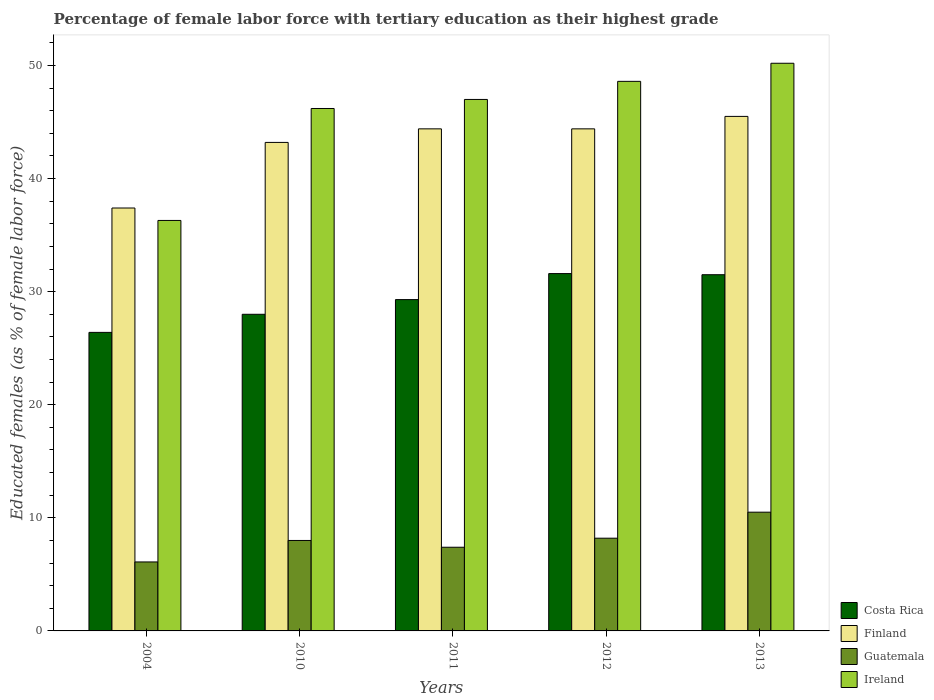How many different coloured bars are there?
Your answer should be compact. 4. How many groups of bars are there?
Give a very brief answer. 5. What is the label of the 5th group of bars from the left?
Your answer should be very brief. 2013. In how many cases, is the number of bars for a given year not equal to the number of legend labels?
Ensure brevity in your answer.  0. What is the percentage of female labor force with tertiary education in Costa Rica in 2012?
Ensure brevity in your answer.  31.6. Across all years, what is the maximum percentage of female labor force with tertiary education in Costa Rica?
Give a very brief answer. 31.6. Across all years, what is the minimum percentage of female labor force with tertiary education in Ireland?
Offer a very short reply. 36.3. In which year was the percentage of female labor force with tertiary education in Ireland minimum?
Ensure brevity in your answer.  2004. What is the total percentage of female labor force with tertiary education in Ireland in the graph?
Give a very brief answer. 228.3. What is the difference between the percentage of female labor force with tertiary education in Costa Rica in 2004 and that in 2010?
Your response must be concise. -1.6. What is the difference between the percentage of female labor force with tertiary education in Finland in 2012 and the percentage of female labor force with tertiary education in Guatemala in 2004?
Offer a terse response. 38.3. What is the average percentage of female labor force with tertiary education in Guatemala per year?
Your answer should be compact. 8.04. In the year 2010, what is the difference between the percentage of female labor force with tertiary education in Ireland and percentage of female labor force with tertiary education in Costa Rica?
Your response must be concise. 18.2. What is the ratio of the percentage of female labor force with tertiary education in Guatemala in 2011 to that in 2013?
Give a very brief answer. 0.7. What is the difference between the highest and the second highest percentage of female labor force with tertiary education in Ireland?
Provide a short and direct response. 1.6. What is the difference between the highest and the lowest percentage of female labor force with tertiary education in Ireland?
Give a very brief answer. 13.9. In how many years, is the percentage of female labor force with tertiary education in Costa Rica greater than the average percentage of female labor force with tertiary education in Costa Rica taken over all years?
Provide a succinct answer. 2. Is the sum of the percentage of female labor force with tertiary education in Ireland in 2004 and 2012 greater than the maximum percentage of female labor force with tertiary education in Guatemala across all years?
Provide a succinct answer. Yes. Is it the case that in every year, the sum of the percentage of female labor force with tertiary education in Finland and percentage of female labor force with tertiary education in Costa Rica is greater than the sum of percentage of female labor force with tertiary education in Ireland and percentage of female labor force with tertiary education in Guatemala?
Your answer should be very brief. Yes. What does the 1st bar from the left in 2004 represents?
Keep it short and to the point. Costa Rica. What does the 2nd bar from the right in 2004 represents?
Keep it short and to the point. Guatemala. How many bars are there?
Give a very brief answer. 20. What is the difference between two consecutive major ticks on the Y-axis?
Provide a short and direct response. 10. Are the values on the major ticks of Y-axis written in scientific E-notation?
Your response must be concise. No. Where does the legend appear in the graph?
Keep it short and to the point. Bottom right. What is the title of the graph?
Offer a terse response. Percentage of female labor force with tertiary education as their highest grade. Does "Nicaragua" appear as one of the legend labels in the graph?
Offer a terse response. No. What is the label or title of the X-axis?
Make the answer very short. Years. What is the label or title of the Y-axis?
Offer a terse response. Educated females (as % of female labor force). What is the Educated females (as % of female labor force) in Costa Rica in 2004?
Offer a terse response. 26.4. What is the Educated females (as % of female labor force) in Finland in 2004?
Offer a very short reply. 37.4. What is the Educated females (as % of female labor force) in Guatemala in 2004?
Keep it short and to the point. 6.1. What is the Educated females (as % of female labor force) of Ireland in 2004?
Offer a very short reply. 36.3. What is the Educated females (as % of female labor force) in Finland in 2010?
Ensure brevity in your answer.  43.2. What is the Educated females (as % of female labor force) of Ireland in 2010?
Provide a succinct answer. 46.2. What is the Educated females (as % of female labor force) of Costa Rica in 2011?
Offer a terse response. 29.3. What is the Educated females (as % of female labor force) of Finland in 2011?
Give a very brief answer. 44.4. What is the Educated females (as % of female labor force) in Guatemala in 2011?
Your answer should be very brief. 7.4. What is the Educated females (as % of female labor force) in Costa Rica in 2012?
Keep it short and to the point. 31.6. What is the Educated females (as % of female labor force) of Finland in 2012?
Give a very brief answer. 44.4. What is the Educated females (as % of female labor force) in Guatemala in 2012?
Offer a very short reply. 8.2. What is the Educated females (as % of female labor force) in Ireland in 2012?
Make the answer very short. 48.6. What is the Educated females (as % of female labor force) in Costa Rica in 2013?
Your response must be concise. 31.5. What is the Educated females (as % of female labor force) in Finland in 2013?
Make the answer very short. 45.5. What is the Educated females (as % of female labor force) of Ireland in 2013?
Offer a terse response. 50.2. Across all years, what is the maximum Educated females (as % of female labor force) of Costa Rica?
Your response must be concise. 31.6. Across all years, what is the maximum Educated females (as % of female labor force) in Finland?
Keep it short and to the point. 45.5. Across all years, what is the maximum Educated females (as % of female labor force) in Ireland?
Provide a succinct answer. 50.2. Across all years, what is the minimum Educated females (as % of female labor force) in Costa Rica?
Offer a very short reply. 26.4. Across all years, what is the minimum Educated females (as % of female labor force) in Finland?
Ensure brevity in your answer.  37.4. Across all years, what is the minimum Educated females (as % of female labor force) in Guatemala?
Your answer should be compact. 6.1. Across all years, what is the minimum Educated females (as % of female labor force) of Ireland?
Provide a succinct answer. 36.3. What is the total Educated females (as % of female labor force) of Costa Rica in the graph?
Ensure brevity in your answer.  146.8. What is the total Educated females (as % of female labor force) in Finland in the graph?
Give a very brief answer. 214.9. What is the total Educated females (as % of female labor force) of Guatemala in the graph?
Make the answer very short. 40.2. What is the total Educated females (as % of female labor force) of Ireland in the graph?
Offer a terse response. 228.3. What is the difference between the Educated females (as % of female labor force) in Finland in 2004 and that in 2010?
Your answer should be very brief. -5.8. What is the difference between the Educated females (as % of female labor force) of Guatemala in 2004 and that in 2010?
Make the answer very short. -1.9. What is the difference between the Educated females (as % of female labor force) in Ireland in 2004 and that in 2010?
Your answer should be very brief. -9.9. What is the difference between the Educated females (as % of female labor force) of Costa Rica in 2004 and that in 2012?
Your answer should be compact. -5.2. What is the difference between the Educated females (as % of female labor force) of Finland in 2004 and that in 2012?
Your answer should be compact. -7. What is the difference between the Educated females (as % of female labor force) of Guatemala in 2004 and that in 2012?
Your response must be concise. -2.1. What is the difference between the Educated females (as % of female labor force) in Costa Rica in 2004 and that in 2013?
Provide a short and direct response. -5.1. What is the difference between the Educated females (as % of female labor force) of Guatemala in 2004 and that in 2013?
Provide a short and direct response. -4.4. What is the difference between the Educated females (as % of female labor force) in Costa Rica in 2010 and that in 2011?
Your response must be concise. -1.3. What is the difference between the Educated females (as % of female labor force) of Finland in 2010 and that in 2011?
Make the answer very short. -1.2. What is the difference between the Educated females (as % of female labor force) in Guatemala in 2010 and that in 2011?
Make the answer very short. 0.6. What is the difference between the Educated females (as % of female labor force) in Ireland in 2010 and that in 2011?
Make the answer very short. -0.8. What is the difference between the Educated females (as % of female labor force) of Guatemala in 2010 and that in 2013?
Your answer should be compact. -2.5. What is the difference between the Educated females (as % of female labor force) in Finland in 2011 and that in 2012?
Keep it short and to the point. 0. What is the difference between the Educated females (as % of female labor force) in Guatemala in 2011 and that in 2012?
Provide a short and direct response. -0.8. What is the difference between the Educated females (as % of female labor force) of Ireland in 2011 and that in 2012?
Make the answer very short. -1.6. What is the difference between the Educated females (as % of female labor force) in Finland in 2011 and that in 2013?
Offer a very short reply. -1.1. What is the difference between the Educated females (as % of female labor force) in Guatemala in 2011 and that in 2013?
Give a very brief answer. -3.1. What is the difference between the Educated females (as % of female labor force) of Ireland in 2011 and that in 2013?
Your answer should be compact. -3.2. What is the difference between the Educated females (as % of female labor force) in Finland in 2012 and that in 2013?
Offer a terse response. -1.1. What is the difference between the Educated females (as % of female labor force) in Costa Rica in 2004 and the Educated females (as % of female labor force) in Finland in 2010?
Your answer should be compact. -16.8. What is the difference between the Educated females (as % of female labor force) in Costa Rica in 2004 and the Educated females (as % of female labor force) in Ireland in 2010?
Ensure brevity in your answer.  -19.8. What is the difference between the Educated females (as % of female labor force) of Finland in 2004 and the Educated females (as % of female labor force) of Guatemala in 2010?
Your response must be concise. 29.4. What is the difference between the Educated females (as % of female labor force) in Finland in 2004 and the Educated females (as % of female labor force) in Ireland in 2010?
Offer a very short reply. -8.8. What is the difference between the Educated females (as % of female labor force) in Guatemala in 2004 and the Educated females (as % of female labor force) in Ireland in 2010?
Give a very brief answer. -40.1. What is the difference between the Educated females (as % of female labor force) of Costa Rica in 2004 and the Educated females (as % of female labor force) of Ireland in 2011?
Offer a terse response. -20.6. What is the difference between the Educated females (as % of female labor force) in Finland in 2004 and the Educated females (as % of female labor force) in Ireland in 2011?
Your answer should be compact. -9.6. What is the difference between the Educated females (as % of female labor force) in Guatemala in 2004 and the Educated females (as % of female labor force) in Ireland in 2011?
Your answer should be compact. -40.9. What is the difference between the Educated females (as % of female labor force) of Costa Rica in 2004 and the Educated females (as % of female labor force) of Finland in 2012?
Your response must be concise. -18. What is the difference between the Educated females (as % of female labor force) of Costa Rica in 2004 and the Educated females (as % of female labor force) of Guatemala in 2012?
Your answer should be very brief. 18.2. What is the difference between the Educated females (as % of female labor force) in Costa Rica in 2004 and the Educated females (as % of female labor force) in Ireland in 2012?
Provide a short and direct response. -22.2. What is the difference between the Educated females (as % of female labor force) of Finland in 2004 and the Educated females (as % of female labor force) of Guatemala in 2012?
Your response must be concise. 29.2. What is the difference between the Educated females (as % of female labor force) of Finland in 2004 and the Educated females (as % of female labor force) of Ireland in 2012?
Provide a short and direct response. -11.2. What is the difference between the Educated females (as % of female labor force) of Guatemala in 2004 and the Educated females (as % of female labor force) of Ireland in 2012?
Make the answer very short. -42.5. What is the difference between the Educated females (as % of female labor force) in Costa Rica in 2004 and the Educated females (as % of female labor force) in Finland in 2013?
Provide a succinct answer. -19.1. What is the difference between the Educated females (as % of female labor force) in Costa Rica in 2004 and the Educated females (as % of female labor force) in Ireland in 2013?
Offer a terse response. -23.8. What is the difference between the Educated females (as % of female labor force) in Finland in 2004 and the Educated females (as % of female labor force) in Guatemala in 2013?
Provide a short and direct response. 26.9. What is the difference between the Educated females (as % of female labor force) of Guatemala in 2004 and the Educated females (as % of female labor force) of Ireland in 2013?
Keep it short and to the point. -44.1. What is the difference between the Educated females (as % of female labor force) in Costa Rica in 2010 and the Educated females (as % of female labor force) in Finland in 2011?
Keep it short and to the point. -16.4. What is the difference between the Educated females (as % of female labor force) of Costa Rica in 2010 and the Educated females (as % of female labor force) of Guatemala in 2011?
Ensure brevity in your answer.  20.6. What is the difference between the Educated females (as % of female labor force) of Finland in 2010 and the Educated females (as % of female labor force) of Guatemala in 2011?
Offer a terse response. 35.8. What is the difference between the Educated females (as % of female labor force) in Guatemala in 2010 and the Educated females (as % of female labor force) in Ireland in 2011?
Make the answer very short. -39. What is the difference between the Educated females (as % of female labor force) of Costa Rica in 2010 and the Educated females (as % of female labor force) of Finland in 2012?
Provide a succinct answer. -16.4. What is the difference between the Educated females (as % of female labor force) in Costa Rica in 2010 and the Educated females (as % of female labor force) in Guatemala in 2012?
Offer a very short reply. 19.8. What is the difference between the Educated females (as % of female labor force) in Costa Rica in 2010 and the Educated females (as % of female labor force) in Ireland in 2012?
Keep it short and to the point. -20.6. What is the difference between the Educated females (as % of female labor force) in Finland in 2010 and the Educated females (as % of female labor force) in Ireland in 2012?
Give a very brief answer. -5.4. What is the difference between the Educated females (as % of female labor force) of Guatemala in 2010 and the Educated females (as % of female labor force) of Ireland in 2012?
Ensure brevity in your answer.  -40.6. What is the difference between the Educated females (as % of female labor force) in Costa Rica in 2010 and the Educated females (as % of female labor force) in Finland in 2013?
Provide a short and direct response. -17.5. What is the difference between the Educated females (as % of female labor force) of Costa Rica in 2010 and the Educated females (as % of female labor force) of Ireland in 2013?
Your answer should be very brief. -22.2. What is the difference between the Educated females (as % of female labor force) in Finland in 2010 and the Educated females (as % of female labor force) in Guatemala in 2013?
Make the answer very short. 32.7. What is the difference between the Educated females (as % of female labor force) of Finland in 2010 and the Educated females (as % of female labor force) of Ireland in 2013?
Ensure brevity in your answer.  -7. What is the difference between the Educated females (as % of female labor force) of Guatemala in 2010 and the Educated females (as % of female labor force) of Ireland in 2013?
Ensure brevity in your answer.  -42.2. What is the difference between the Educated females (as % of female labor force) in Costa Rica in 2011 and the Educated females (as % of female labor force) in Finland in 2012?
Offer a very short reply. -15.1. What is the difference between the Educated females (as % of female labor force) of Costa Rica in 2011 and the Educated females (as % of female labor force) of Guatemala in 2012?
Your response must be concise. 21.1. What is the difference between the Educated females (as % of female labor force) in Costa Rica in 2011 and the Educated females (as % of female labor force) in Ireland in 2012?
Keep it short and to the point. -19.3. What is the difference between the Educated females (as % of female labor force) in Finland in 2011 and the Educated females (as % of female labor force) in Guatemala in 2012?
Ensure brevity in your answer.  36.2. What is the difference between the Educated females (as % of female labor force) in Guatemala in 2011 and the Educated females (as % of female labor force) in Ireland in 2012?
Give a very brief answer. -41.2. What is the difference between the Educated females (as % of female labor force) of Costa Rica in 2011 and the Educated females (as % of female labor force) of Finland in 2013?
Make the answer very short. -16.2. What is the difference between the Educated females (as % of female labor force) in Costa Rica in 2011 and the Educated females (as % of female labor force) in Guatemala in 2013?
Give a very brief answer. 18.8. What is the difference between the Educated females (as % of female labor force) in Costa Rica in 2011 and the Educated females (as % of female labor force) in Ireland in 2013?
Offer a very short reply. -20.9. What is the difference between the Educated females (as % of female labor force) of Finland in 2011 and the Educated females (as % of female labor force) of Guatemala in 2013?
Ensure brevity in your answer.  33.9. What is the difference between the Educated females (as % of female labor force) of Finland in 2011 and the Educated females (as % of female labor force) of Ireland in 2013?
Keep it short and to the point. -5.8. What is the difference between the Educated females (as % of female labor force) of Guatemala in 2011 and the Educated females (as % of female labor force) of Ireland in 2013?
Keep it short and to the point. -42.8. What is the difference between the Educated females (as % of female labor force) in Costa Rica in 2012 and the Educated females (as % of female labor force) in Finland in 2013?
Ensure brevity in your answer.  -13.9. What is the difference between the Educated females (as % of female labor force) of Costa Rica in 2012 and the Educated females (as % of female labor force) of Guatemala in 2013?
Keep it short and to the point. 21.1. What is the difference between the Educated females (as % of female labor force) in Costa Rica in 2012 and the Educated females (as % of female labor force) in Ireland in 2013?
Offer a terse response. -18.6. What is the difference between the Educated females (as % of female labor force) in Finland in 2012 and the Educated females (as % of female labor force) in Guatemala in 2013?
Your response must be concise. 33.9. What is the difference between the Educated females (as % of female labor force) in Finland in 2012 and the Educated females (as % of female labor force) in Ireland in 2013?
Give a very brief answer. -5.8. What is the difference between the Educated females (as % of female labor force) of Guatemala in 2012 and the Educated females (as % of female labor force) of Ireland in 2013?
Offer a terse response. -42. What is the average Educated females (as % of female labor force) of Costa Rica per year?
Your answer should be very brief. 29.36. What is the average Educated females (as % of female labor force) in Finland per year?
Offer a very short reply. 42.98. What is the average Educated females (as % of female labor force) of Guatemala per year?
Offer a very short reply. 8.04. What is the average Educated females (as % of female labor force) of Ireland per year?
Your response must be concise. 45.66. In the year 2004, what is the difference between the Educated females (as % of female labor force) in Costa Rica and Educated females (as % of female labor force) in Finland?
Your answer should be very brief. -11. In the year 2004, what is the difference between the Educated females (as % of female labor force) in Costa Rica and Educated females (as % of female labor force) in Guatemala?
Ensure brevity in your answer.  20.3. In the year 2004, what is the difference between the Educated females (as % of female labor force) of Finland and Educated females (as % of female labor force) of Guatemala?
Offer a very short reply. 31.3. In the year 2004, what is the difference between the Educated females (as % of female labor force) in Finland and Educated females (as % of female labor force) in Ireland?
Ensure brevity in your answer.  1.1. In the year 2004, what is the difference between the Educated females (as % of female labor force) in Guatemala and Educated females (as % of female labor force) in Ireland?
Offer a terse response. -30.2. In the year 2010, what is the difference between the Educated females (as % of female labor force) in Costa Rica and Educated females (as % of female labor force) in Finland?
Keep it short and to the point. -15.2. In the year 2010, what is the difference between the Educated females (as % of female labor force) in Costa Rica and Educated females (as % of female labor force) in Ireland?
Offer a terse response. -18.2. In the year 2010, what is the difference between the Educated females (as % of female labor force) of Finland and Educated females (as % of female labor force) of Guatemala?
Provide a succinct answer. 35.2. In the year 2010, what is the difference between the Educated females (as % of female labor force) of Guatemala and Educated females (as % of female labor force) of Ireland?
Make the answer very short. -38.2. In the year 2011, what is the difference between the Educated females (as % of female labor force) of Costa Rica and Educated females (as % of female labor force) of Finland?
Your answer should be compact. -15.1. In the year 2011, what is the difference between the Educated females (as % of female labor force) of Costa Rica and Educated females (as % of female labor force) of Guatemala?
Offer a very short reply. 21.9. In the year 2011, what is the difference between the Educated females (as % of female labor force) of Costa Rica and Educated females (as % of female labor force) of Ireland?
Ensure brevity in your answer.  -17.7. In the year 2011, what is the difference between the Educated females (as % of female labor force) of Finland and Educated females (as % of female labor force) of Ireland?
Give a very brief answer. -2.6. In the year 2011, what is the difference between the Educated females (as % of female labor force) of Guatemala and Educated females (as % of female labor force) of Ireland?
Give a very brief answer. -39.6. In the year 2012, what is the difference between the Educated females (as % of female labor force) of Costa Rica and Educated females (as % of female labor force) of Guatemala?
Ensure brevity in your answer.  23.4. In the year 2012, what is the difference between the Educated females (as % of female labor force) of Costa Rica and Educated females (as % of female labor force) of Ireland?
Make the answer very short. -17. In the year 2012, what is the difference between the Educated females (as % of female labor force) of Finland and Educated females (as % of female labor force) of Guatemala?
Ensure brevity in your answer.  36.2. In the year 2012, what is the difference between the Educated females (as % of female labor force) of Guatemala and Educated females (as % of female labor force) of Ireland?
Offer a terse response. -40.4. In the year 2013, what is the difference between the Educated females (as % of female labor force) in Costa Rica and Educated females (as % of female labor force) in Finland?
Your response must be concise. -14. In the year 2013, what is the difference between the Educated females (as % of female labor force) in Costa Rica and Educated females (as % of female labor force) in Ireland?
Offer a very short reply. -18.7. In the year 2013, what is the difference between the Educated females (as % of female labor force) of Finland and Educated females (as % of female labor force) of Ireland?
Your answer should be very brief. -4.7. In the year 2013, what is the difference between the Educated females (as % of female labor force) in Guatemala and Educated females (as % of female labor force) in Ireland?
Give a very brief answer. -39.7. What is the ratio of the Educated females (as % of female labor force) in Costa Rica in 2004 to that in 2010?
Your answer should be very brief. 0.94. What is the ratio of the Educated females (as % of female labor force) in Finland in 2004 to that in 2010?
Your answer should be compact. 0.87. What is the ratio of the Educated females (as % of female labor force) in Guatemala in 2004 to that in 2010?
Ensure brevity in your answer.  0.76. What is the ratio of the Educated females (as % of female labor force) of Ireland in 2004 to that in 2010?
Keep it short and to the point. 0.79. What is the ratio of the Educated females (as % of female labor force) in Costa Rica in 2004 to that in 2011?
Provide a short and direct response. 0.9. What is the ratio of the Educated females (as % of female labor force) in Finland in 2004 to that in 2011?
Make the answer very short. 0.84. What is the ratio of the Educated females (as % of female labor force) of Guatemala in 2004 to that in 2011?
Provide a succinct answer. 0.82. What is the ratio of the Educated females (as % of female labor force) in Ireland in 2004 to that in 2011?
Provide a succinct answer. 0.77. What is the ratio of the Educated females (as % of female labor force) in Costa Rica in 2004 to that in 2012?
Provide a succinct answer. 0.84. What is the ratio of the Educated females (as % of female labor force) in Finland in 2004 to that in 2012?
Keep it short and to the point. 0.84. What is the ratio of the Educated females (as % of female labor force) of Guatemala in 2004 to that in 2012?
Provide a short and direct response. 0.74. What is the ratio of the Educated females (as % of female labor force) in Ireland in 2004 to that in 2012?
Make the answer very short. 0.75. What is the ratio of the Educated females (as % of female labor force) in Costa Rica in 2004 to that in 2013?
Ensure brevity in your answer.  0.84. What is the ratio of the Educated females (as % of female labor force) of Finland in 2004 to that in 2013?
Ensure brevity in your answer.  0.82. What is the ratio of the Educated females (as % of female labor force) of Guatemala in 2004 to that in 2013?
Your response must be concise. 0.58. What is the ratio of the Educated females (as % of female labor force) in Ireland in 2004 to that in 2013?
Offer a very short reply. 0.72. What is the ratio of the Educated females (as % of female labor force) of Costa Rica in 2010 to that in 2011?
Your answer should be very brief. 0.96. What is the ratio of the Educated females (as % of female labor force) in Guatemala in 2010 to that in 2011?
Provide a succinct answer. 1.08. What is the ratio of the Educated females (as % of female labor force) of Costa Rica in 2010 to that in 2012?
Your response must be concise. 0.89. What is the ratio of the Educated females (as % of female labor force) in Finland in 2010 to that in 2012?
Your answer should be very brief. 0.97. What is the ratio of the Educated females (as % of female labor force) in Guatemala in 2010 to that in 2012?
Your answer should be very brief. 0.98. What is the ratio of the Educated females (as % of female labor force) of Ireland in 2010 to that in 2012?
Keep it short and to the point. 0.95. What is the ratio of the Educated females (as % of female labor force) of Finland in 2010 to that in 2013?
Make the answer very short. 0.95. What is the ratio of the Educated females (as % of female labor force) of Guatemala in 2010 to that in 2013?
Make the answer very short. 0.76. What is the ratio of the Educated females (as % of female labor force) of Ireland in 2010 to that in 2013?
Offer a terse response. 0.92. What is the ratio of the Educated females (as % of female labor force) of Costa Rica in 2011 to that in 2012?
Your answer should be very brief. 0.93. What is the ratio of the Educated females (as % of female labor force) in Guatemala in 2011 to that in 2012?
Your response must be concise. 0.9. What is the ratio of the Educated females (as % of female labor force) in Ireland in 2011 to that in 2012?
Keep it short and to the point. 0.97. What is the ratio of the Educated females (as % of female labor force) of Costa Rica in 2011 to that in 2013?
Make the answer very short. 0.93. What is the ratio of the Educated females (as % of female labor force) of Finland in 2011 to that in 2013?
Offer a very short reply. 0.98. What is the ratio of the Educated females (as % of female labor force) in Guatemala in 2011 to that in 2013?
Offer a very short reply. 0.7. What is the ratio of the Educated females (as % of female labor force) of Ireland in 2011 to that in 2013?
Your response must be concise. 0.94. What is the ratio of the Educated females (as % of female labor force) in Costa Rica in 2012 to that in 2013?
Your answer should be compact. 1. What is the ratio of the Educated females (as % of female labor force) of Finland in 2012 to that in 2013?
Offer a very short reply. 0.98. What is the ratio of the Educated females (as % of female labor force) in Guatemala in 2012 to that in 2013?
Keep it short and to the point. 0.78. What is the ratio of the Educated females (as % of female labor force) in Ireland in 2012 to that in 2013?
Offer a terse response. 0.97. What is the difference between the highest and the second highest Educated females (as % of female labor force) in Costa Rica?
Your answer should be compact. 0.1. What is the difference between the highest and the second highest Educated females (as % of female labor force) of Finland?
Offer a terse response. 1.1. What is the difference between the highest and the lowest Educated females (as % of female labor force) of Costa Rica?
Make the answer very short. 5.2. What is the difference between the highest and the lowest Educated females (as % of female labor force) in Finland?
Your answer should be very brief. 8.1. What is the difference between the highest and the lowest Educated females (as % of female labor force) in Guatemala?
Provide a succinct answer. 4.4. What is the difference between the highest and the lowest Educated females (as % of female labor force) of Ireland?
Keep it short and to the point. 13.9. 